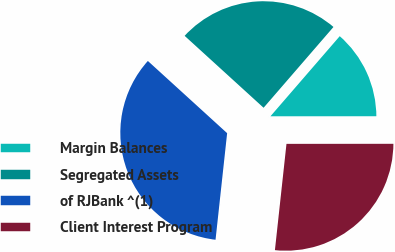<chart> <loc_0><loc_0><loc_500><loc_500><pie_chart><fcel>Margin Balances<fcel>Segregated Assets<fcel>of RJBank ^(1)<fcel>Client Interest Program<nl><fcel>13.64%<fcel>24.59%<fcel>35.03%<fcel>26.73%<nl></chart> 